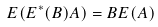Convert formula to latex. <formula><loc_0><loc_0><loc_500><loc_500>E ( E ^ { * } ( B ) A ) = B E ( A )</formula> 